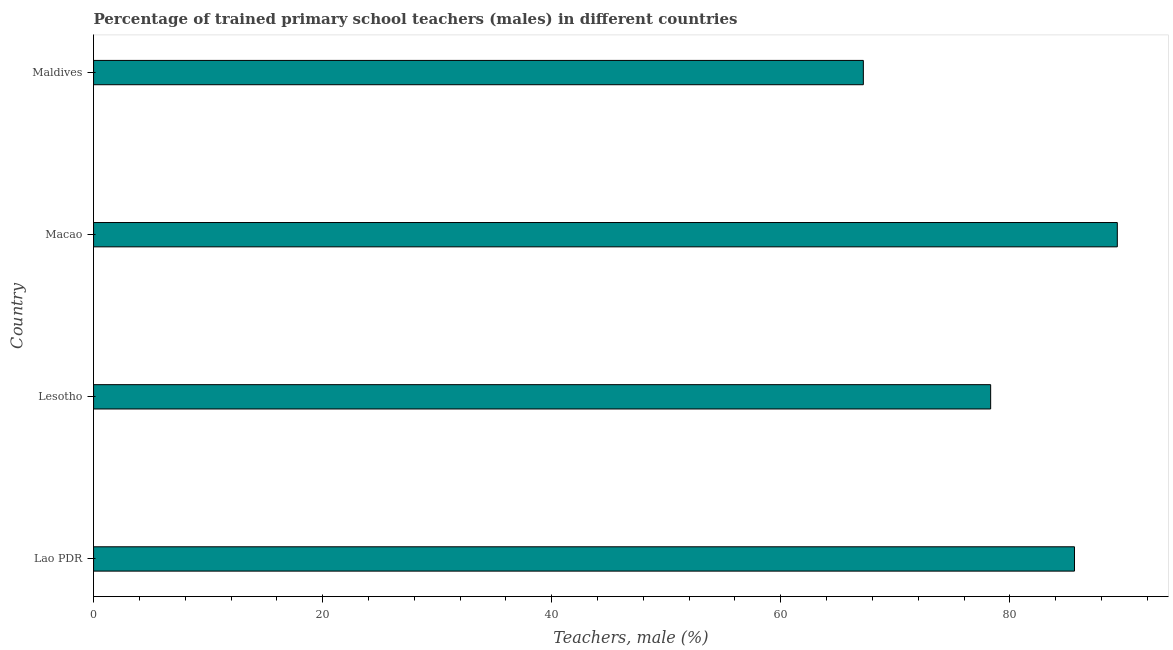What is the title of the graph?
Make the answer very short. Percentage of trained primary school teachers (males) in different countries. What is the label or title of the X-axis?
Offer a terse response. Teachers, male (%). What is the percentage of trained male teachers in Maldives?
Give a very brief answer. 67.21. Across all countries, what is the maximum percentage of trained male teachers?
Provide a succinct answer. 89.38. Across all countries, what is the minimum percentage of trained male teachers?
Your answer should be very brief. 67.21. In which country was the percentage of trained male teachers maximum?
Your response must be concise. Macao. In which country was the percentage of trained male teachers minimum?
Make the answer very short. Maldives. What is the sum of the percentage of trained male teachers?
Provide a short and direct response. 320.54. What is the difference between the percentage of trained male teachers in Lao PDR and Macao?
Offer a very short reply. -3.74. What is the average percentage of trained male teachers per country?
Offer a very short reply. 80.14. What is the median percentage of trained male teachers?
Make the answer very short. 81.98. What is the ratio of the percentage of trained male teachers in Lao PDR to that in Macao?
Provide a succinct answer. 0.96. Is the difference between the percentage of trained male teachers in Lao PDR and Maldives greater than the difference between any two countries?
Provide a short and direct response. No. What is the difference between the highest and the second highest percentage of trained male teachers?
Keep it short and to the point. 3.74. What is the difference between the highest and the lowest percentage of trained male teachers?
Provide a short and direct response. 22.17. How many bars are there?
Your response must be concise. 4. Are all the bars in the graph horizontal?
Your answer should be very brief. Yes. What is the Teachers, male (%) in Lao PDR?
Provide a short and direct response. 85.64. What is the Teachers, male (%) of Lesotho?
Your answer should be very brief. 78.32. What is the Teachers, male (%) of Macao?
Your response must be concise. 89.38. What is the Teachers, male (%) of Maldives?
Provide a short and direct response. 67.21. What is the difference between the Teachers, male (%) in Lao PDR and Lesotho?
Offer a terse response. 7.32. What is the difference between the Teachers, male (%) in Lao PDR and Macao?
Make the answer very short. -3.74. What is the difference between the Teachers, male (%) in Lao PDR and Maldives?
Keep it short and to the point. 18.43. What is the difference between the Teachers, male (%) in Lesotho and Macao?
Your answer should be very brief. -11.06. What is the difference between the Teachers, male (%) in Lesotho and Maldives?
Offer a very short reply. 11.12. What is the difference between the Teachers, male (%) in Macao and Maldives?
Make the answer very short. 22.17. What is the ratio of the Teachers, male (%) in Lao PDR to that in Lesotho?
Your response must be concise. 1.09. What is the ratio of the Teachers, male (%) in Lao PDR to that in Macao?
Keep it short and to the point. 0.96. What is the ratio of the Teachers, male (%) in Lao PDR to that in Maldives?
Keep it short and to the point. 1.27. What is the ratio of the Teachers, male (%) in Lesotho to that in Macao?
Provide a succinct answer. 0.88. What is the ratio of the Teachers, male (%) in Lesotho to that in Maldives?
Keep it short and to the point. 1.17. What is the ratio of the Teachers, male (%) in Macao to that in Maldives?
Your answer should be compact. 1.33. 